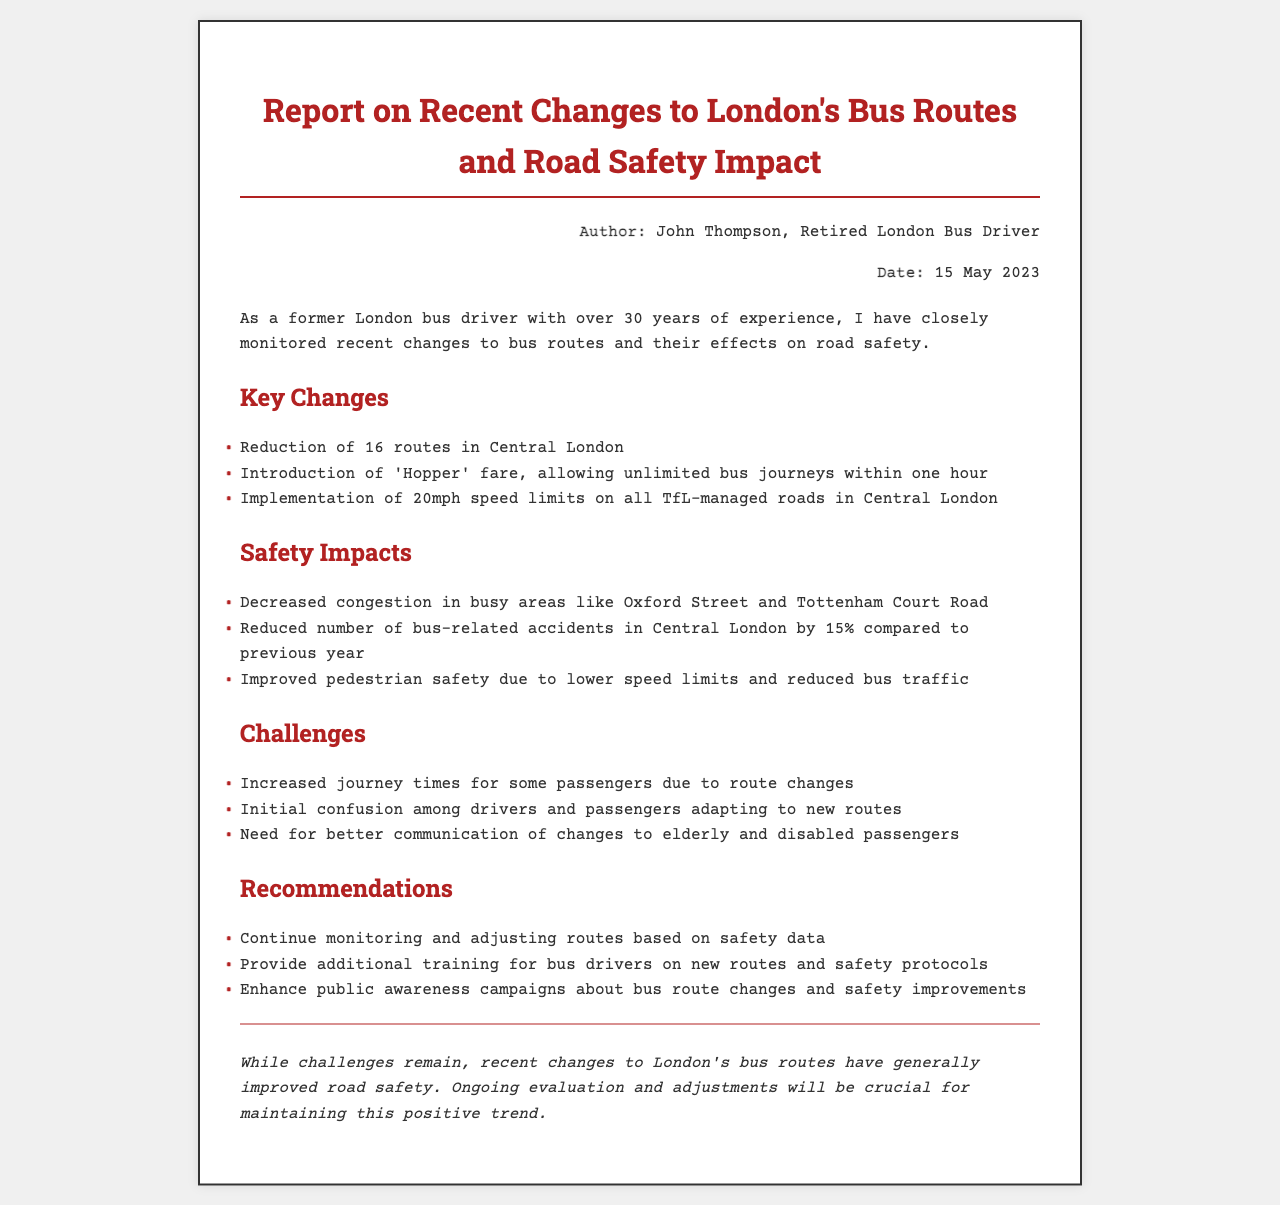what is the date of the report? The report is dated on 15 May 2023 according to the meta-info section.
Answer: 15 May 2023 who authored the report? The author of the report is mentioned as John Thompson, who is a retired London bus driver.
Answer: John Thompson how many routes were reduced in Central London? The report indicates that there was a reduction of 16 routes in Central London.
Answer: 16 what was the percentage decrease in bus-related accidents? The report states that bus-related accidents in Central London were reduced by 15% compared to the previous year.
Answer: 15% what speed limit was implemented on TfL-managed roads? The document specifies the implementation of 20mph speed limits on all TfL-managed roads in Central London.
Answer: 20mph what challenge is mentioned regarding passengers? One challenge discussed is the initial confusion among drivers and passengers adapting to the new routes.
Answer: confusion which fare type was introduced? The report mentions the introduction of the 'Hopper' fare, allowing unlimited bus journeys within one hour.
Answer: 'Hopper' fare what type of campaigns does the report recommend enhancing? The recommendations include enhancing public awareness campaigns about bus route changes and safety improvements.
Answer: public awareness campaigns what is the overall conclusion regarding road safety? The conclusion states that recent changes to London's bus routes have generally improved road safety.
Answer: improved road safety 